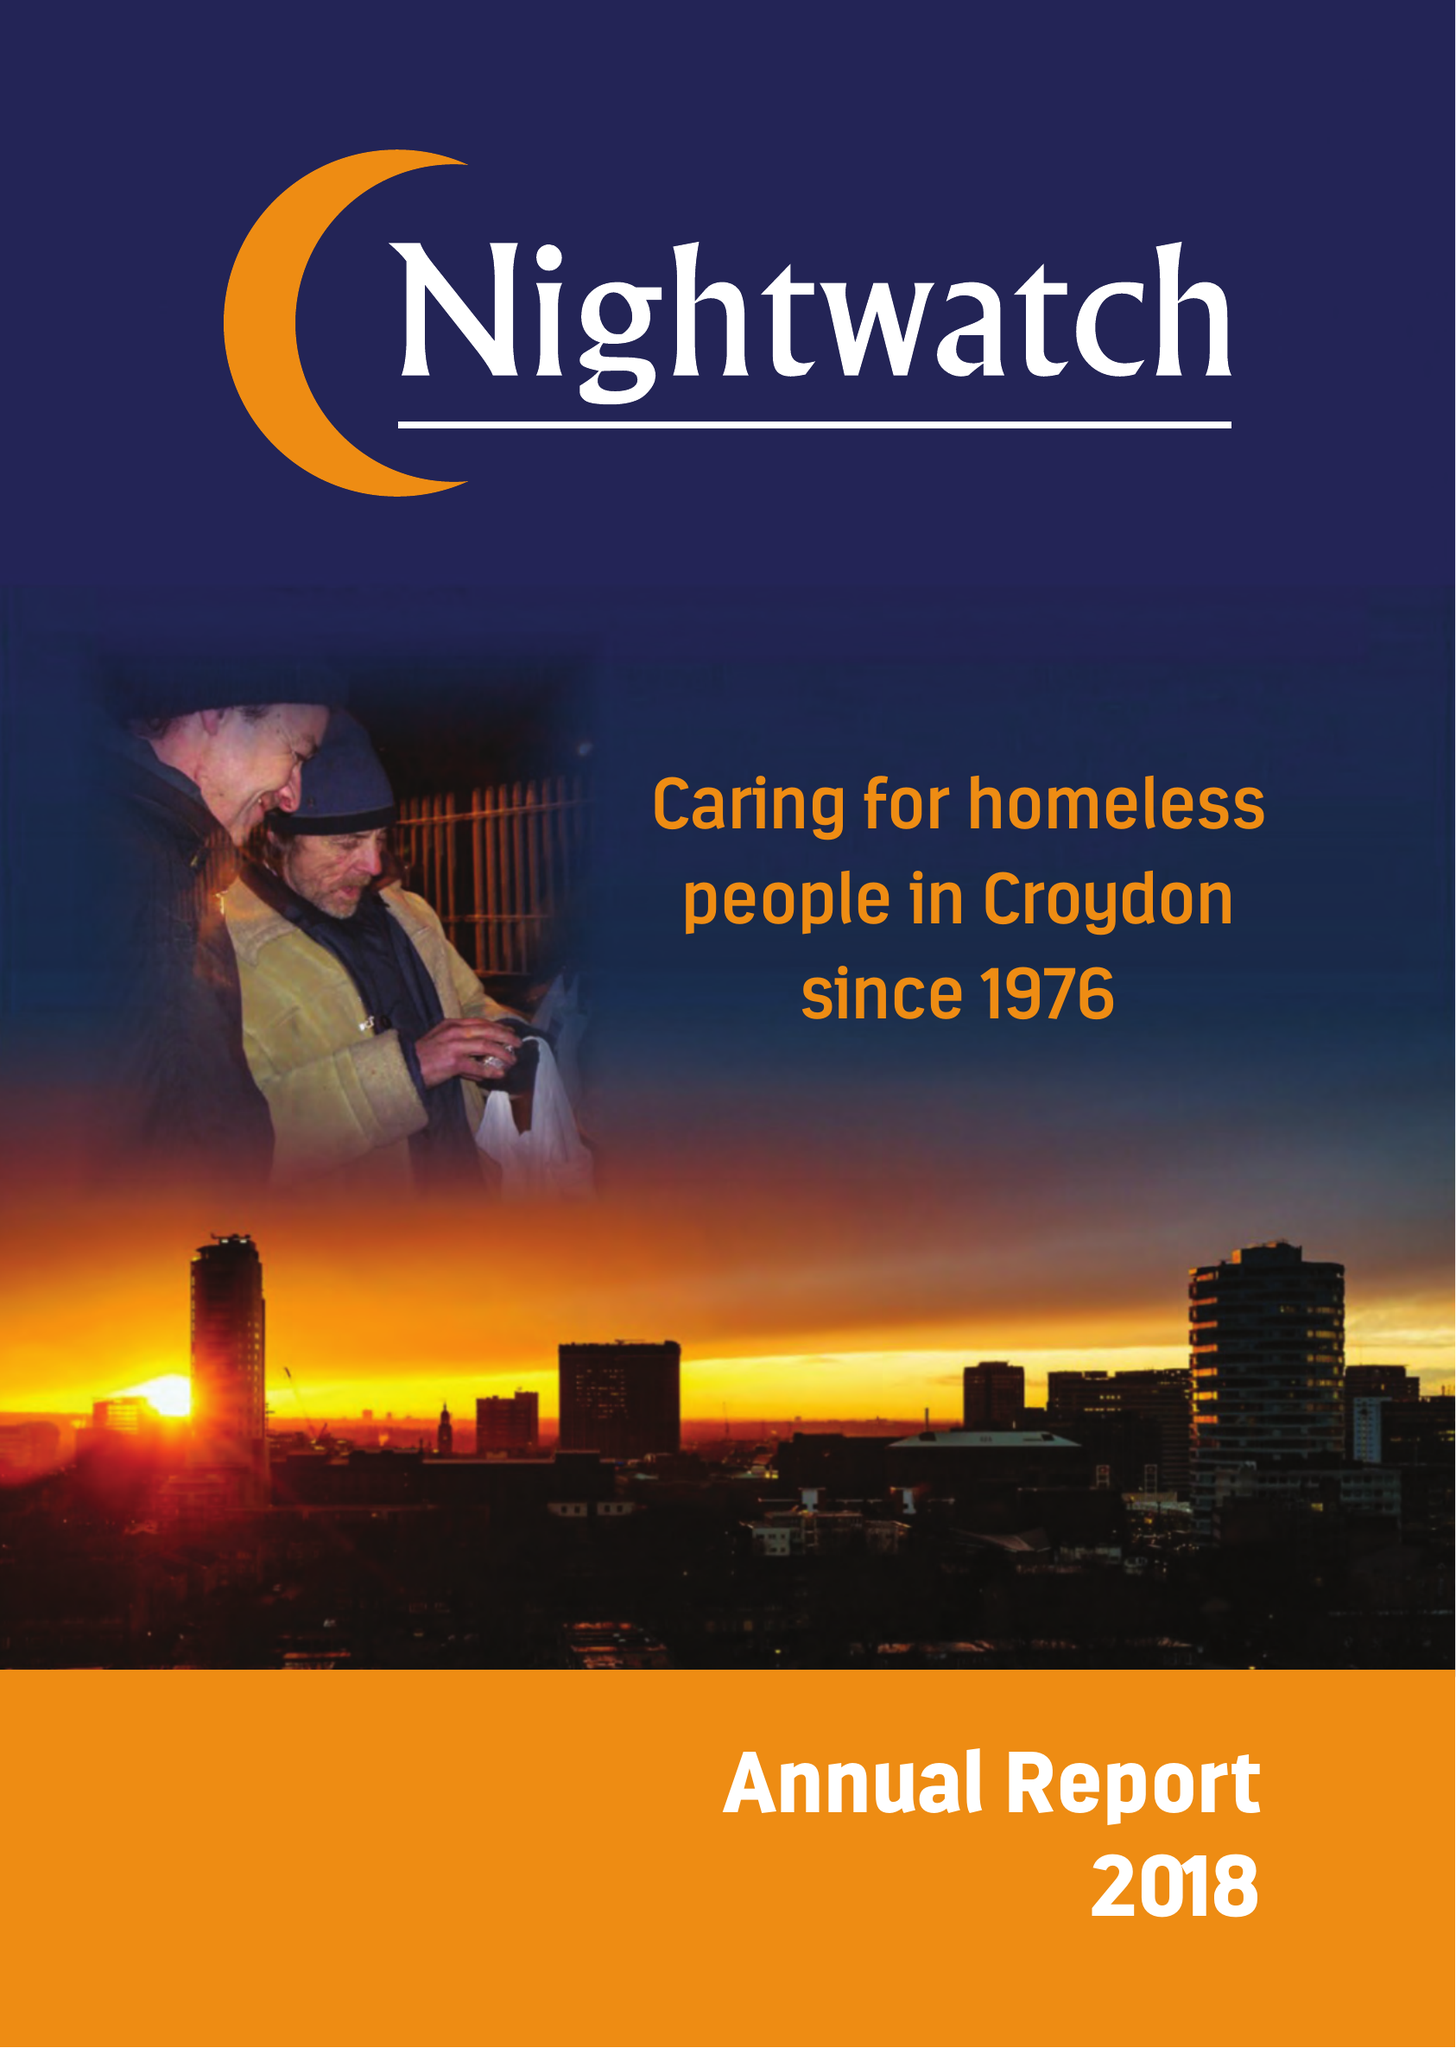What is the value for the address__street_line?
Answer the question using a single word or phrase. PO BOX 9576 